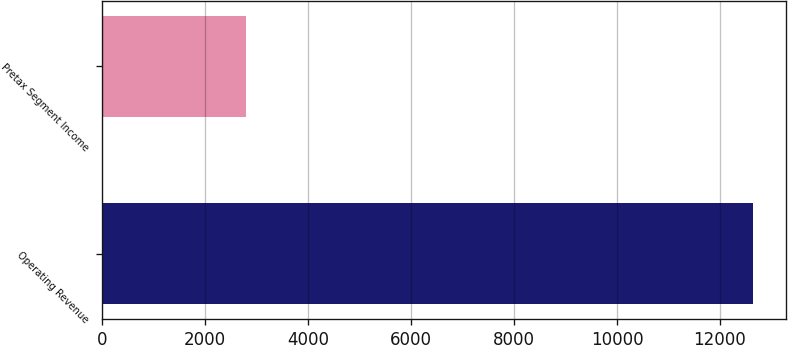Convert chart. <chart><loc_0><loc_0><loc_500><loc_500><bar_chart><fcel>Operating Revenue<fcel>Pretax Segment Income<nl><fcel>12648<fcel>2805<nl></chart> 